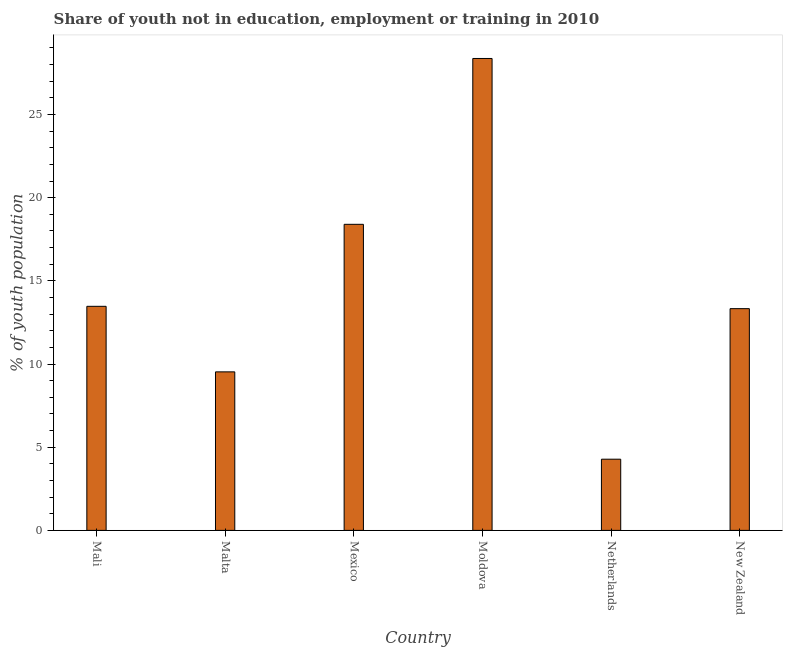Does the graph contain any zero values?
Your response must be concise. No. What is the title of the graph?
Offer a very short reply. Share of youth not in education, employment or training in 2010. What is the label or title of the X-axis?
Keep it short and to the point. Country. What is the label or title of the Y-axis?
Offer a very short reply. % of youth population. What is the unemployed youth population in New Zealand?
Offer a very short reply. 13.33. Across all countries, what is the maximum unemployed youth population?
Your answer should be very brief. 28.37. Across all countries, what is the minimum unemployed youth population?
Offer a very short reply. 4.28. In which country was the unemployed youth population maximum?
Your answer should be very brief. Moldova. In which country was the unemployed youth population minimum?
Your response must be concise. Netherlands. What is the sum of the unemployed youth population?
Keep it short and to the point. 87.38. What is the difference between the unemployed youth population in Mali and Moldova?
Offer a very short reply. -14.9. What is the average unemployed youth population per country?
Provide a short and direct response. 14.56. What is the median unemployed youth population?
Your answer should be very brief. 13.4. In how many countries, is the unemployed youth population greater than 11 %?
Keep it short and to the point. 4. What is the ratio of the unemployed youth population in Mali to that in Mexico?
Offer a terse response. 0.73. Is the unemployed youth population in Malta less than that in New Zealand?
Provide a short and direct response. Yes. What is the difference between the highest and the second highest unemployed youth population?
Provide a short and direct response. 9.97. What is the difference between the highest and the lowest unemployed youth population?
Offer a very short reply. 24.09. Are all the bars in the graph horizontal?
Provide a short and direct response. No. What is the difference between two consecutive major ticks on the Y-axis?
Your answer should be very brief. 5. Are the values on the major ticks of Y-axis written in scientific E-notation?
Make the answer very short. No. What is the % of youth population of Mali?
Provide a short and direct response. 13.47. What is the % of youth population in Malta?
Offer a terse response. 9.53. What is the % of youth population in Mexico?
Keep it short and to the point. 18.4. What is the % of youth population in Moldova?
Your response must be concise. 28.37. What is the % of youth population of Netherlands?
Your answer should be very brief. 4.28. What is the % of youth population in New Zealand?
Offer a very short reply. 13.33. What is the difference between the % of youth population in Mali and Malta?
Make the answer very short. 3.94. What is the difference between the % of youth population in Mali and Mexico?
Make the answer very short. -4.93. What is the difference between the % of youth population in Mali and Moldova?
Offer a very short reply. -14.9. What is the difference between the % of youth population in Mali and Netherlands?
Provide a short and direct response. 9.19. What is the difference between the % of youth population in Mali and New Zealand?
Your answer should be compact. 0.14. What is the difference between the % of youth population in Malta and Mexico?
Make the answer very short. -8.87. What is the difference between the % of youth population in Malta and Moldova?
Ensure brevity in your answer.  -18.84. What is the difference between the % of youth population in Malta and Netherlands?
Your response must be concise. 5.25. What is the difference between the % of youth population in Malta and New Zealand?
Provide a succinct answer. -3.8. What is the difference between the % of youth population in Mexico and Moldova?
Your answer should be very brief. -9.97. What is the difference between the % of youth population in Mexico and Netherlands?
Make the answer very short. 14.12. What is the difference between the % of youth population in Mexico and New Zealand?
Ensure brevity in your answer.  5.07. What is the difference between the % of youth population in Moldova and Netherlands?
Offer a terse response. 24.09. What is the difference between the % of youth population in Moldova and New Zealand?
Your answer should be compact. 15.04. What is the difference between the % of youth population in Netherlands and New Zealand?
Your answer should be very brief. -9.05. What is the ratio of the % of youth population in Mali to that in Malta?
Ensure brevity in your answer.  1.41. What is the ratio of the % of youth population in Mali to that in Mexico?
Your response must be concise. 0.73. What is the ratio of the % of youth population in Mali to that in Moldova?
Provide a succinct answer. 0.47. What is the ratio of the % of youth population in Mali to that in Netherlands?
Offer a very short reply. 3.15. What is the ratio of the % of youth population in Mali to that in New Zealand?
Provide a short and direct response. 1.01. What is the ratio of the % of youth population in Malta to that in Mexico?
Your answer should be compact. 0.52. What is the ratio of the % of youth population in Malta to that in Moldova?
Offer a very short reply. 0.34. What is the ratio of the % of youth population in Malta to that in Netherlands?
Your answer should be compact. 2.23. What is the ratio of the % of youth population in Malta to that in New Zealand?
Offer a very short reply. 0.71. What is the ratio of the % of youth population in Mexico to that in Moldova?
Provide a short and direct response. 0.65. What is the ratio of the % of youth population in Mexico to that in Netherlands?
Make the answer very short. 4.3. What is the ratio of the % of youth population in Mexico to that in New Zealand?
Keep it short and to the point. 1.38. What is the ratio of the % of youth population in Moldova to that in Netherlands?
Ensure brevity in your answer.  6.63. What is the ratio of the % of youth population in Moldova to that in New Zealand?
Your response must be concise. 2.13. What is the ratio of the % of youth population in Netherlands to that in New Zealand?
Make the answer very short. 0.32. 